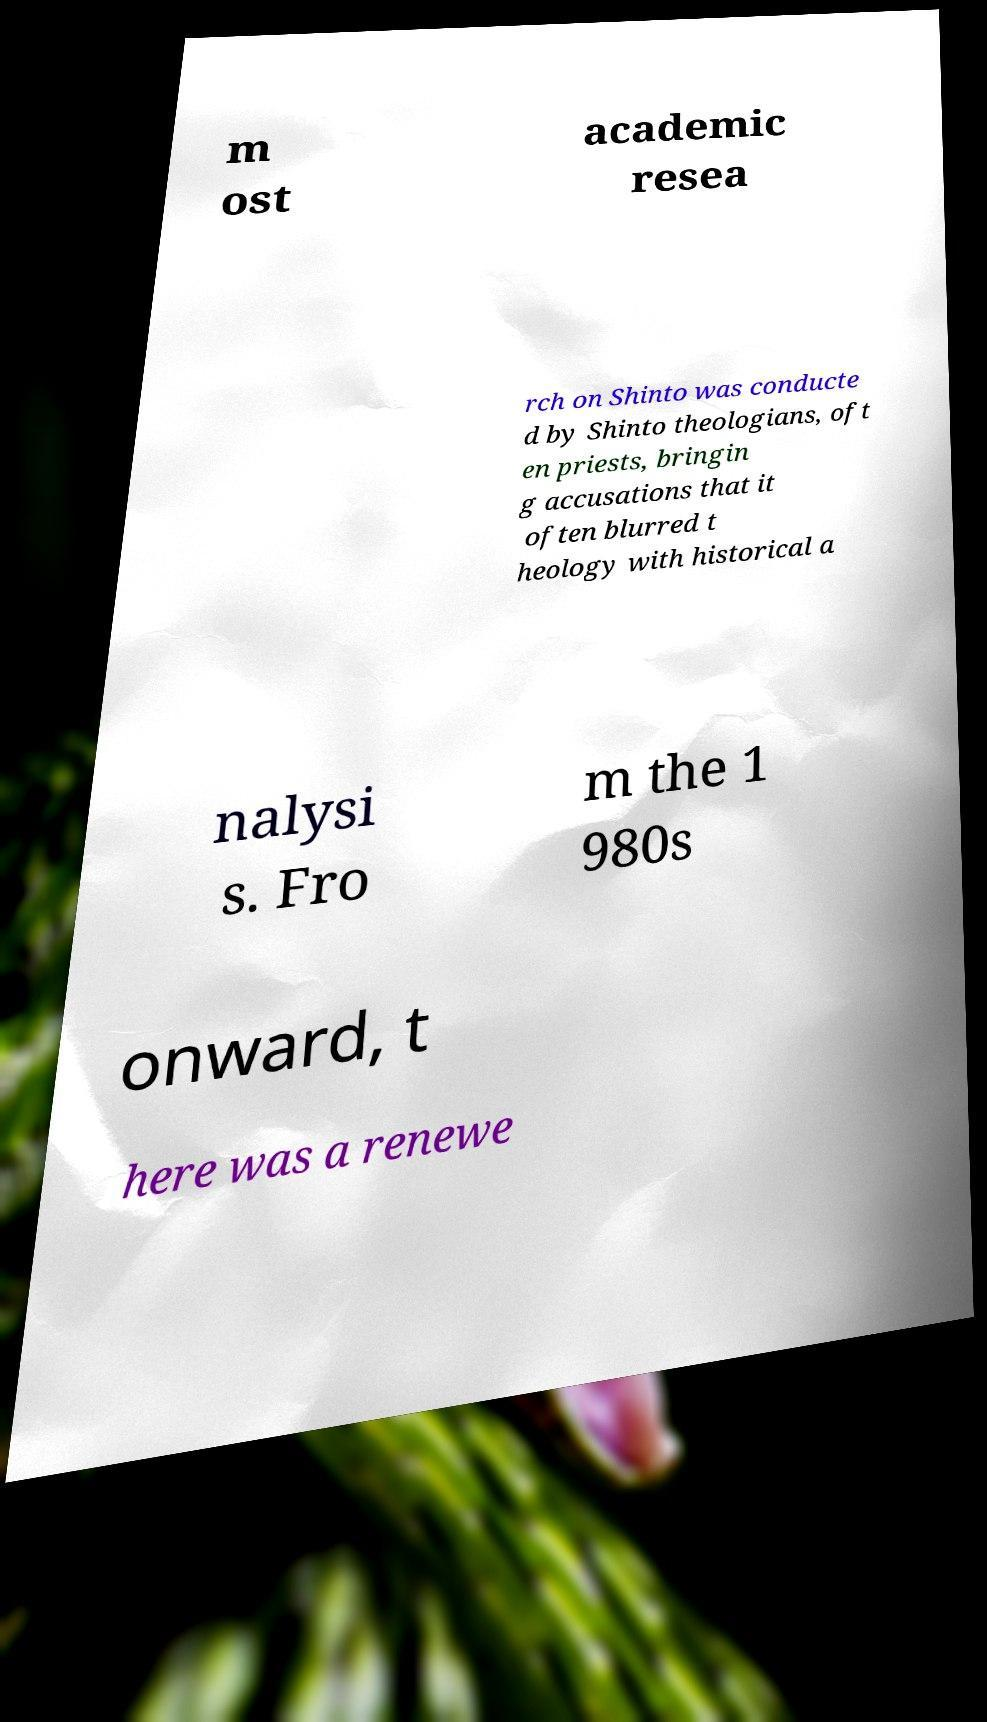I need the written content from this picture converted into text. Can you do that? m ost academic resea rch on Shinto was conducte d by Shinto theologians, oft en priests, bringin g accusations that it often blurred t heology with historical a nalysi s. Fro m the 1 980s onward, t here was a renewe 